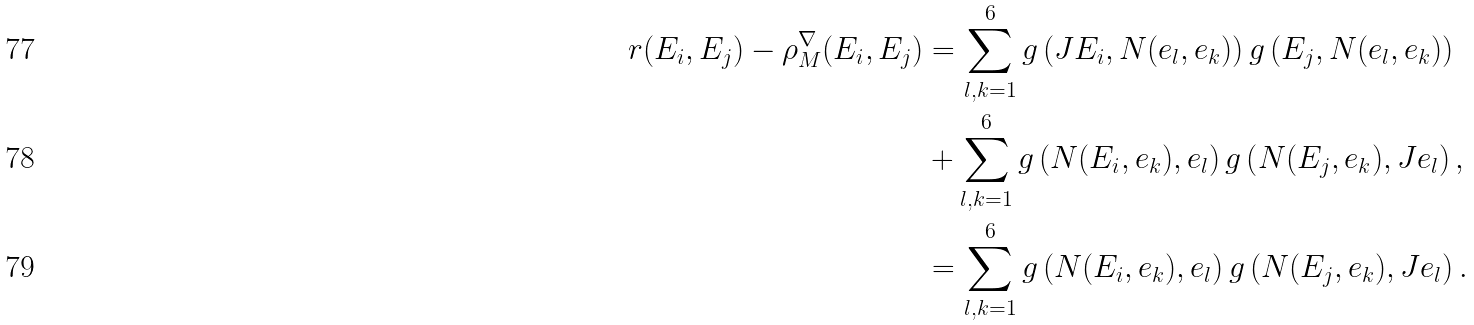<formula> <loc_0><loc_0><loc_500><loc_500>r ( E _ { i } , E _ { j } ) - \rho ^ { \nabla } _ { M } ( E _ { i } , E _ { j } ) & = \sum _ { l , k = 1 } ^ { 6 } g \left ( J E _ { i } , N ( e _ { l } , e _ { k } ) \right ) g \left ( E _ { j } , N ( e _ { l } , e _ { k } ) \right ) \\ & + \sum _ { l , k = 1 } ^ { 6 } g \left ( N ( E _ { i } , e _ { k } ) , e _ { l } \right ) g \left ( N ( E _ { j } , e _ { k } ) , J e _ { l } \right ) , \\ & = \sum _ { l , k = 1 } ^ { 6 } g \left ( N ( E _ { i } , e _ { k } ) , e _ { l } \right ) g \left ( N ( E _ { j } , e _ { k } ) , J e _ { l } \right ) .</formula> 